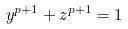<formula> <loc_0><loc_0><loc_500><loc_500>y ^ { p + 1 } + z ^ { p + 1 } = 1</formula> 